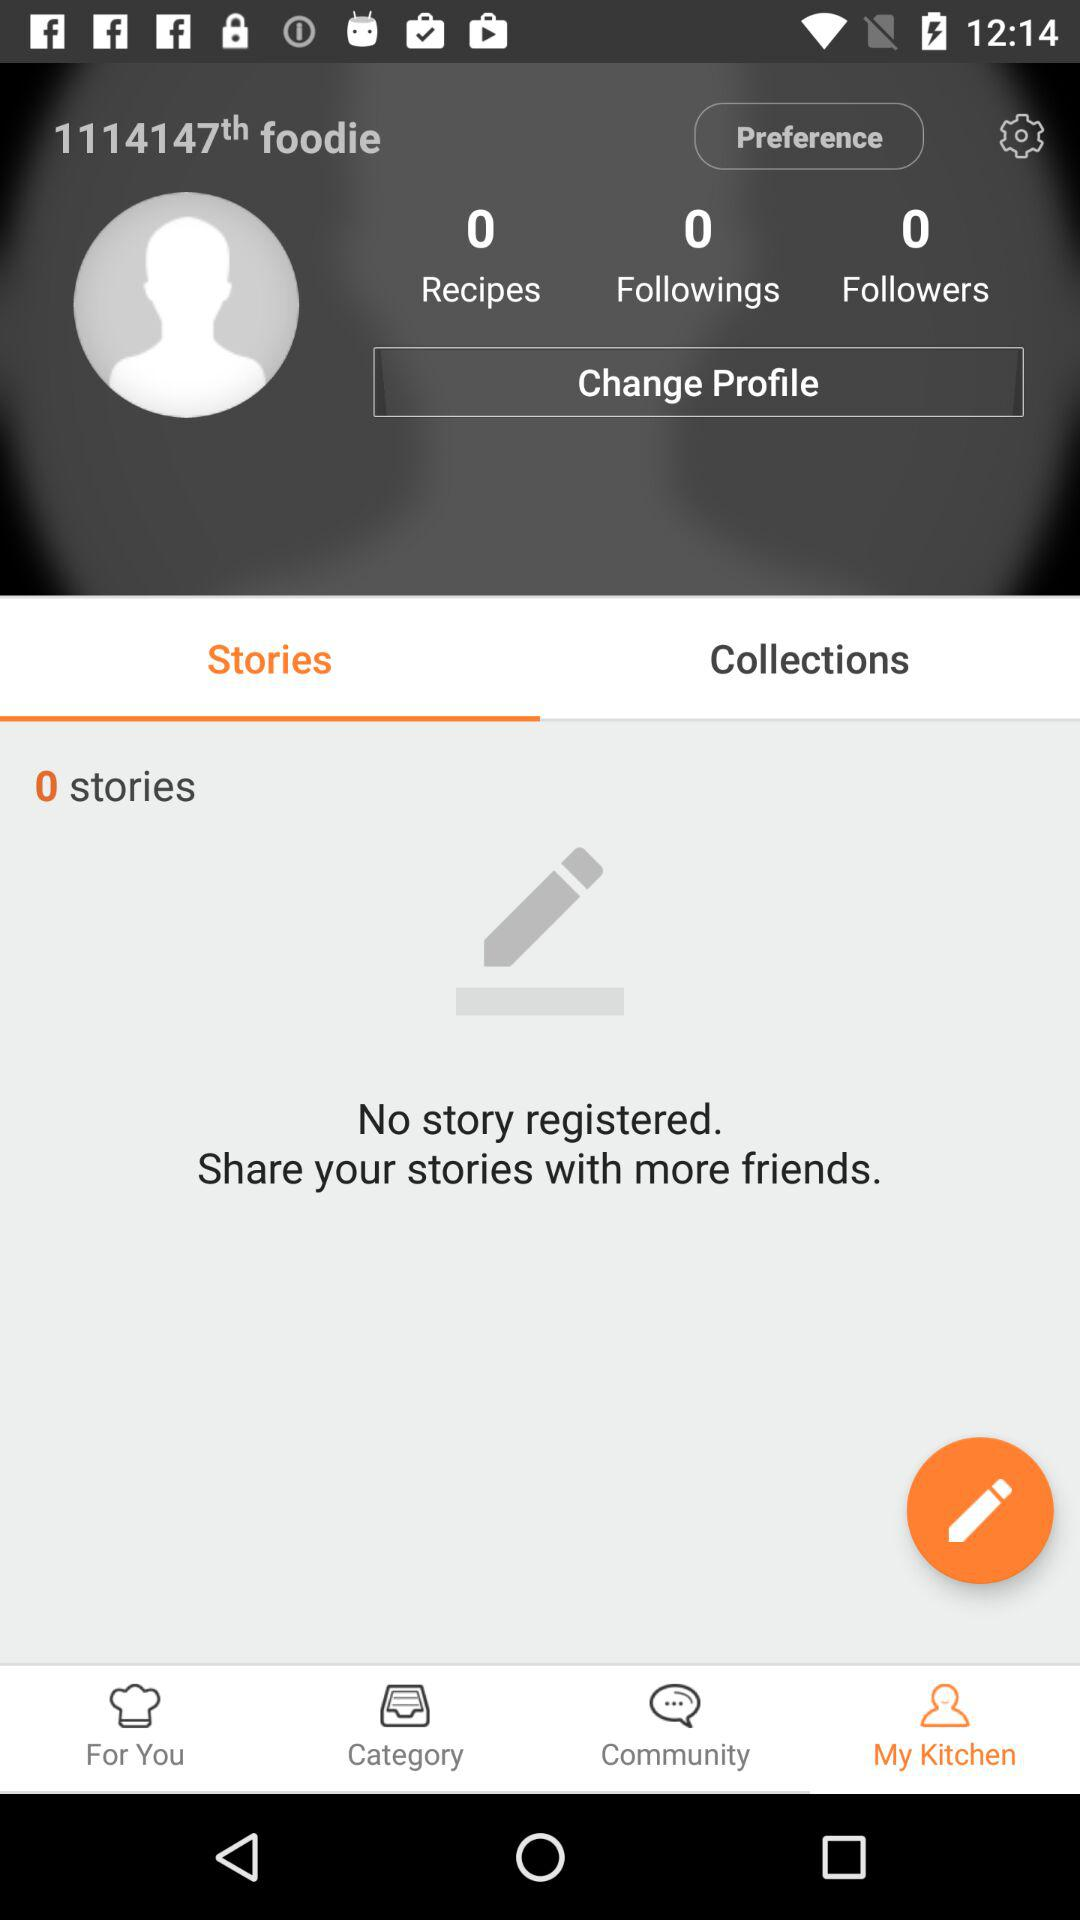How many stories does the user have?
Answer the question using a single word or phrase. 0 